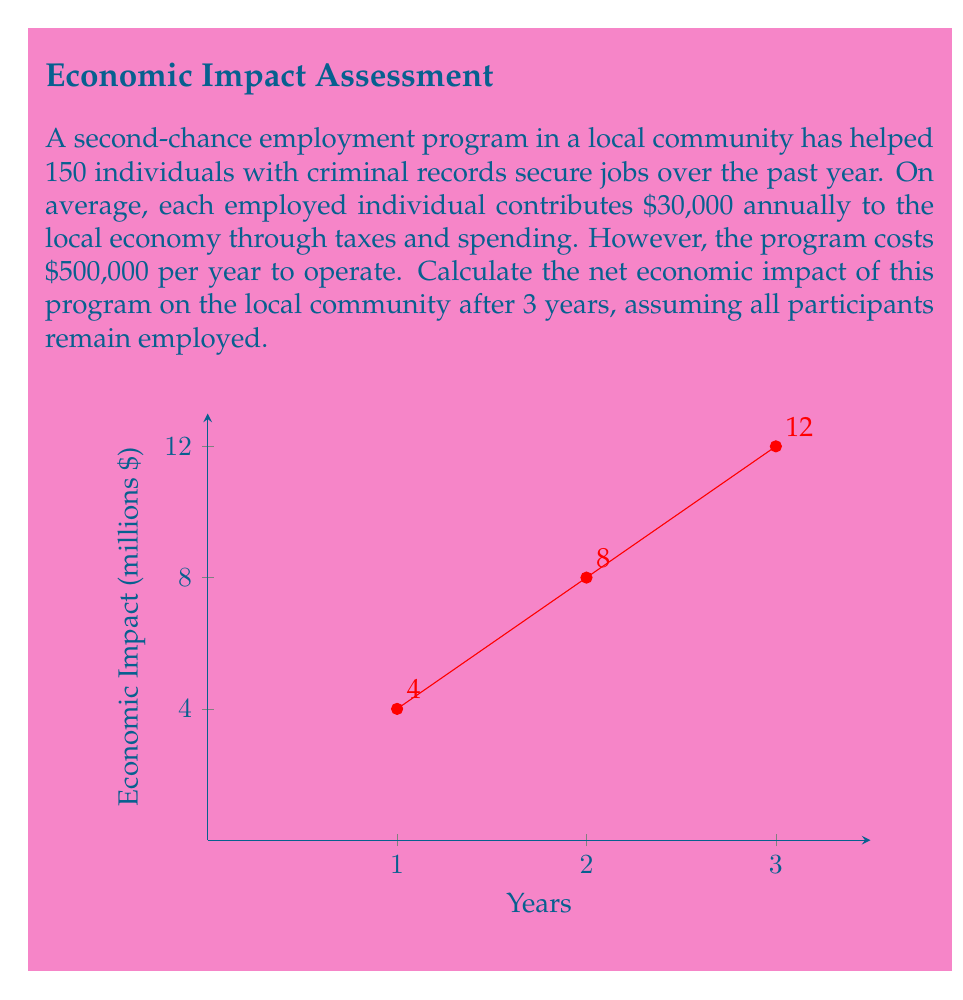Give your solution to this math problem. Let's break this problem down step-by-step:

1) First, calculate the annual economic contribution of all participants:
   $150 \text{ participants} \times \$30,000 = \$4,500,000$

2) Calculate the annual net impact by subtracting the program cost:
   $\$4,500,000 - \$500,000 = \$4,000,000$

3) To find the impact over 3 years, multiply the annual net impact by 3:
   $\$4,000,000 \times 3 = \$12,000,000$

This calculation assumes that:
- The number of participants remains constant at 150.
- Each participant continues to contribute $30,000 annually.
- The program cost remains $500,000 per year.

The graph in the question visualizes this linear growth over the 3-year period, with each point representing the cumulative economic impact at the end of each year.

Year 1: $\$4,000,000$
Year 2: $\$8,000,000$
Year 3: $\$12,000,000$

This demonstrates how the economic impact compounds over time, highlighting the long-term benefits of second-chance employment programs for local communities.
Answer: $\$12,000,000$ 